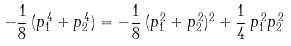<formula> <loc_0><loc_0><loc_500><loc_500>- \frac { 1 } { 8 } \, ( p _ { 1 } ^ { \, 4 } + p _ { 2 } ^ { \, 4 } ) = - \frac { 1 } { 8 } \, ( p _ { 1 } ^ { \, 2 } + p _ { 2 } ^ { \, 2 } ) ^ { 2 } + \frac { 1 } { 4 } \, p _ { 1 } ^ { \, 2 } p _ { 2 } ^ { \, 2 }</formula> 